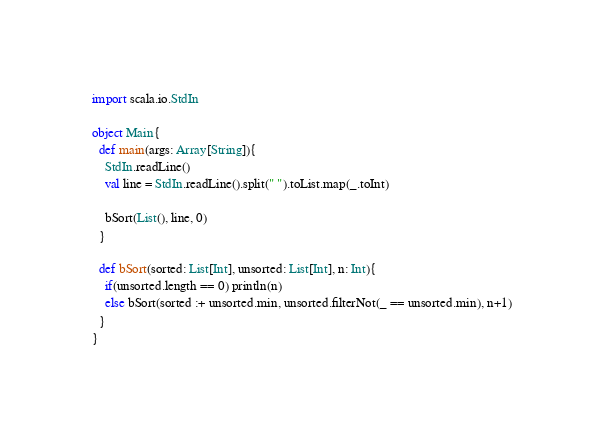Convert code to text. <code><loc_0><loc_0><loc_500><loc_500><_Scala_>import scala.io.StdIn

object Main{
  def main(args: Array[String]){
    StdIn.readLine()
    val line = StdIn.readLine().split(" ").toList.map(_.toInt)

    bSort(List(), line, 0)
  }

  def bSort(sorted: List[Int], unsorted: List[Int], n: Int){
    if(unsorted.length == 0) println(n)
    else bSort(sorted :+ unsorted.min, unsorted.filterNot(_ == unsorted.min), n+1)
  }
}</code> 